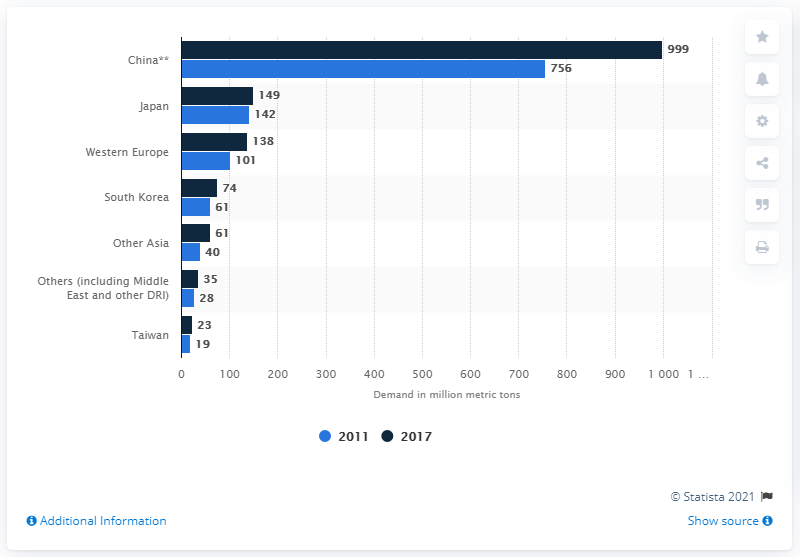Highlight a few significant elements in this photo. What is China's seaborne demand of iron ore expected to amount to in 2017? According to estimates, it is projected to be approximately 999. 